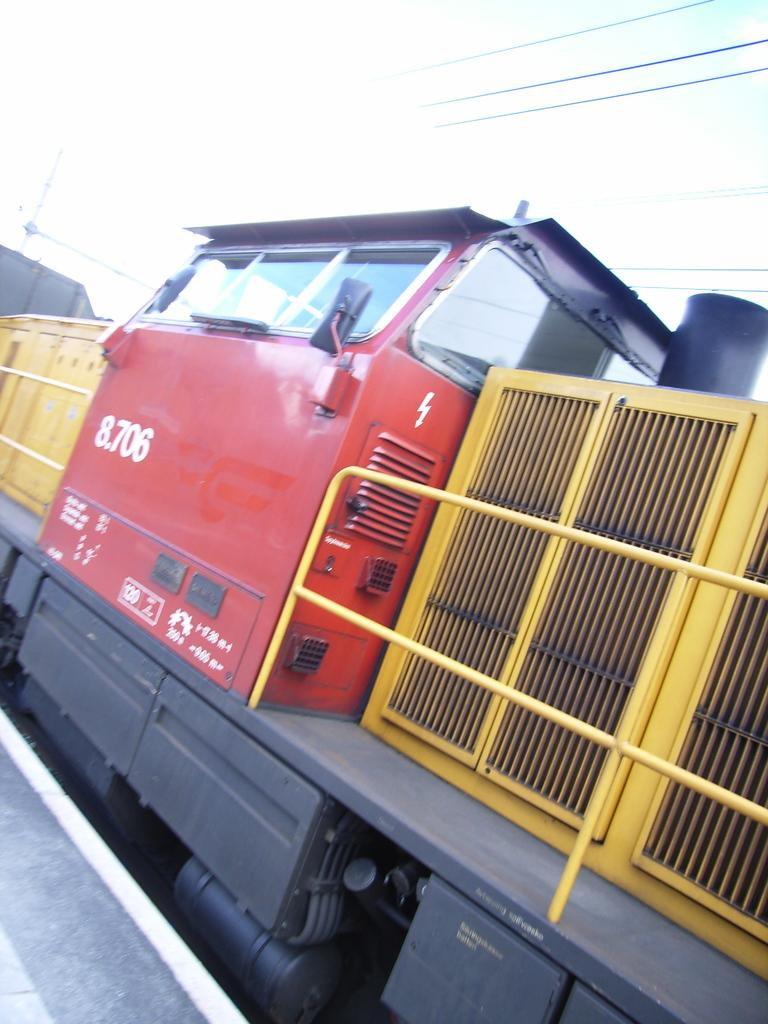What is the main subject of the image? The main subject of the image is a train. Where is the train located in the image? The train is on a track in the image. What can be seen in the background of the image? There are cables and the sky visible in the background of the image. What type of crime is being committed by the train in the image? There is no crime being committed by the train in the image; it is simply a train on a track. Are there any slaves visible in the image? There are no slaves present in the image. 